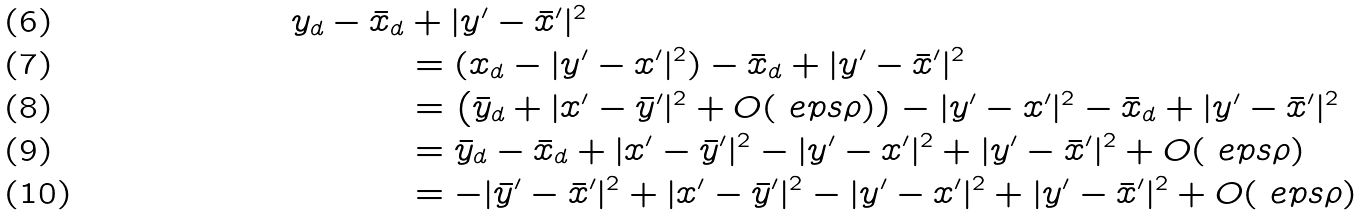Convert formula to latex. <formula><loc_0><loc_0><loc_500><loc_500>y _ { d } - \bar { x } _ { d } & + | y ^ { \prime } - \bar { x } ^ { \prime } | ^ { 2 } \\ & = ( x _ { d } - | y ^ { \prime } - x ^ { \prime } | ^ { 2 } ) - \bar { x } _ { d } + | y ^ { \prime } - \bar { x } ^ { \prime } | ^ { 2 } \\ & = \left ( \bar { y } _ { d } + | x ^ { \prime } - \bar { y } ^ { \prime } | ^ { 2 } + O ( \ e p s \rho ) \right ) - | y ^ { \prime } - x ^ { \prime } | ^ { 2 } - \bar { x } _ { d } + | y ^ { \prime } - \bar { x } ^ { \prime } | ^ { 2 } \\ & = \bar { y } _ { d } - \bar { x } _ { d } + | x ^ { \prime } - \bar { y } ^ { \prime } | ^ { 2 } - | y ^ { \prime } - x ^ { \prime } | ^ { 2 } + | y ^ { \prime } - \bar { x } ^ { \prime } | ^ { 2 } + O ( \ e p s \rho ) \\ & = - | \bar { y } ^ { \prime } - \bar { x } ^ { \prime } | ^ { 2 } + | x ^ { \prime } - \bar { y } ^ { \prime } | ^ { 2 } - | y ^ { \prime } - x ^ { \prime } | ^ { 2 } + | y ^ { \prime } - \bar { x } ^ { \prime } | ^ { 2 } + O ( \ e p s \rho )</formula> 